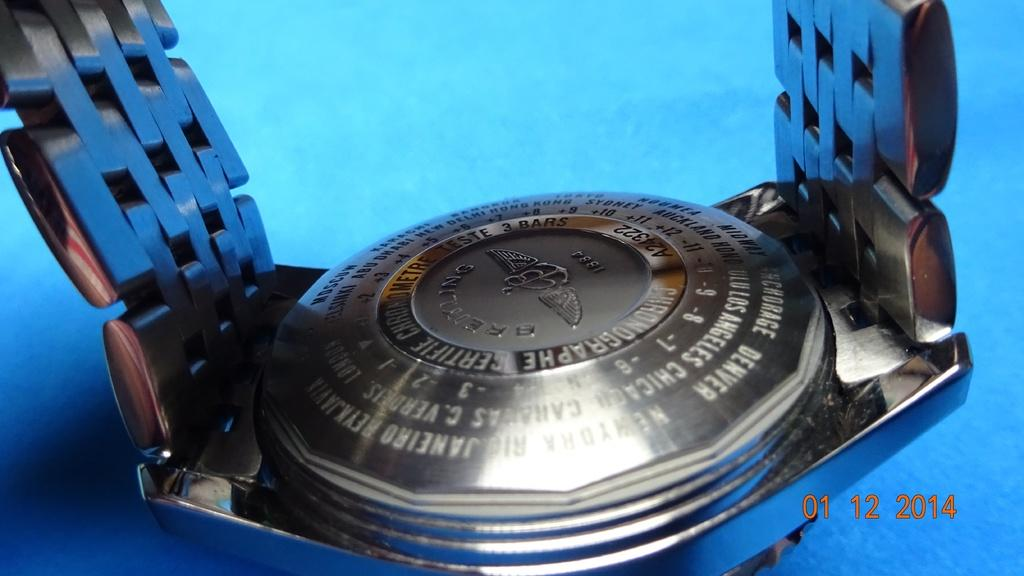<image>
Present a compact description of the photo's key features. a silver item that was photographed in the year 2014 